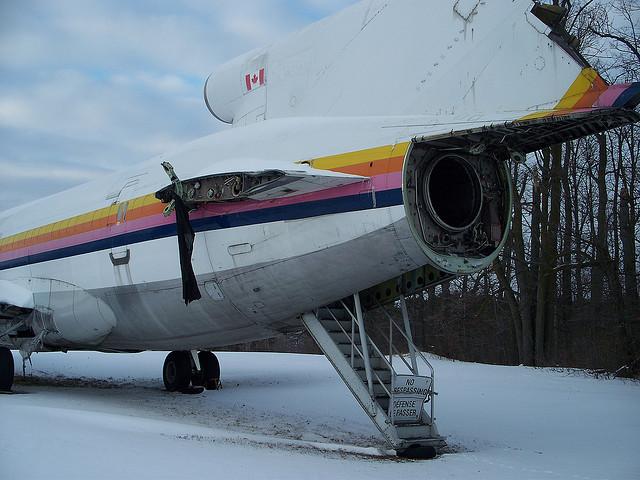Are you allowed to enter the aircraft?
Keep it brief. No. How many stripes are on the plane?
Concise answer only. 4. What flag is on the airplane?
Concise answer only. Canada. 